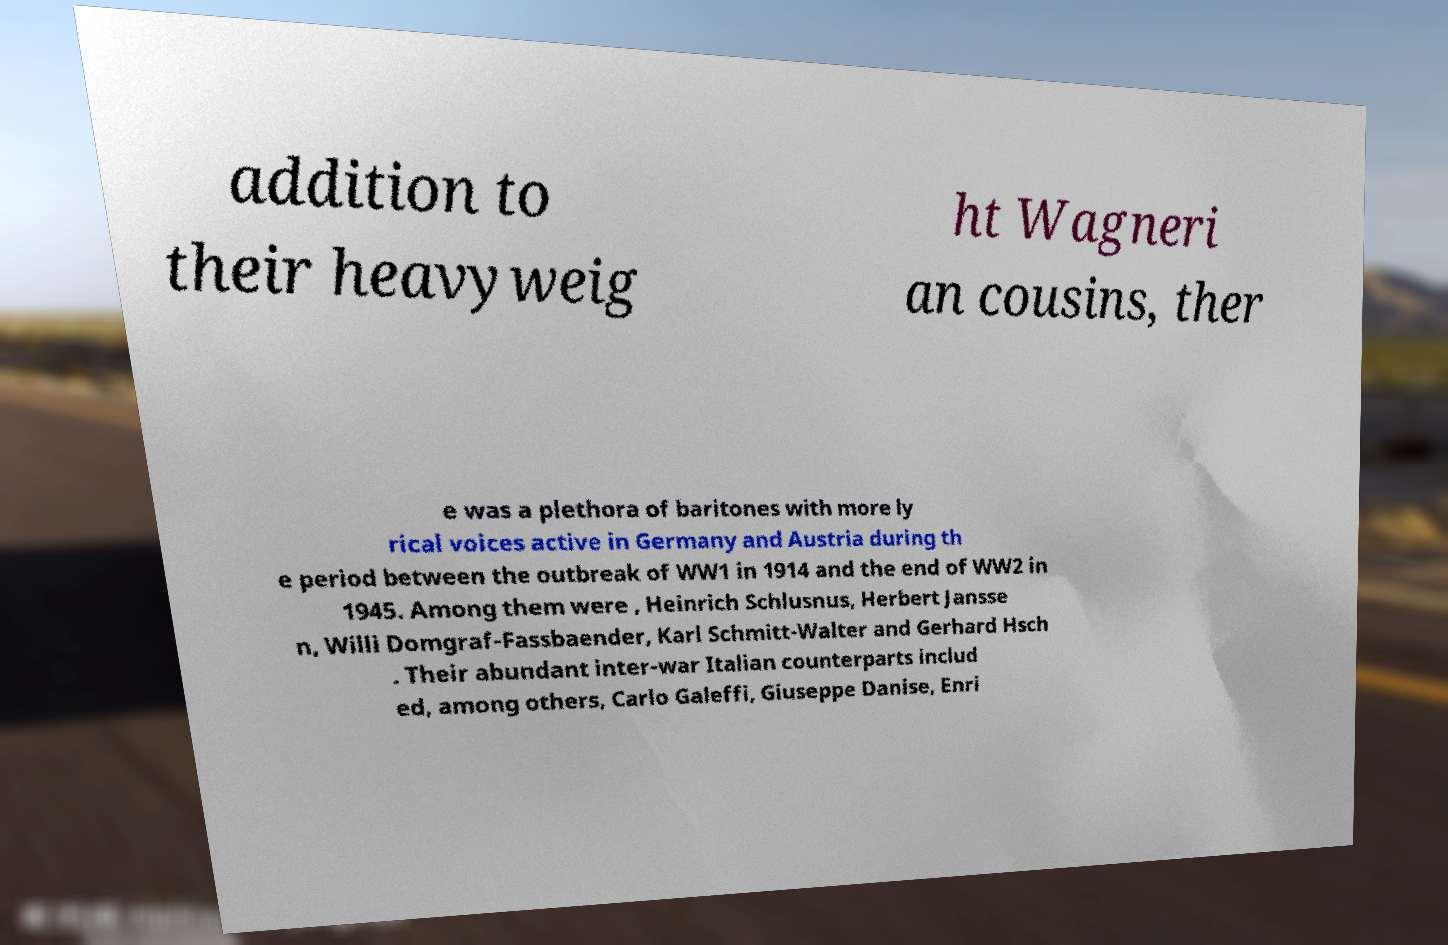Can you accurately transcribe the text from the provided image for me? addition to their heavyweig ht Wagneri an cousins, ther e was a plethora of baritones with more ly rical voices active in Germany and Austria during th e period between the outbreak of WW1 in 1914 and the end of WW2 in 1945. Among them were , Heinrich Schlusnus, Herbert Jansse n, Willi Domgraf-Fassbaender, Karl Schmitt-Walter and Gerhard Hsch . Their abundant inter-war Italian counterparts includ ed, among others, Carlo Galeffi, Giuseppe Danise, Enri 